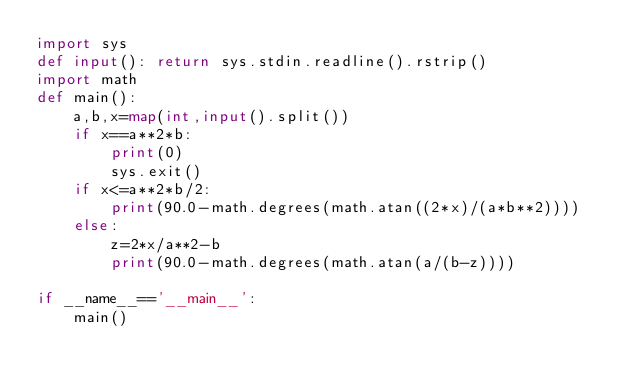<code> <loc_0><loc_0><loc_500><loc_500><_Python_>import sys
def input(): return sys.stdin.readline().rstrip()
import math
def main():
    a,b,x=map(int,input().split())
    if x==a**2*b:
        print(0)
        sys.exit()
    if x<=a**2*b/2:
        print(90.0-math.degrees(math.atan((2*x)/(a*b**2))))
    else:
        z=2*x/a**2-b
        print(90.0-math.degrees(math.atan(a/(b-z))))

if __name__=='__main__':
    main()</code> 